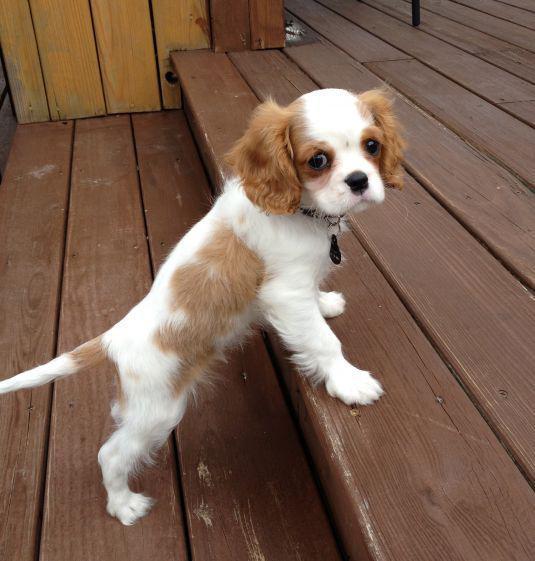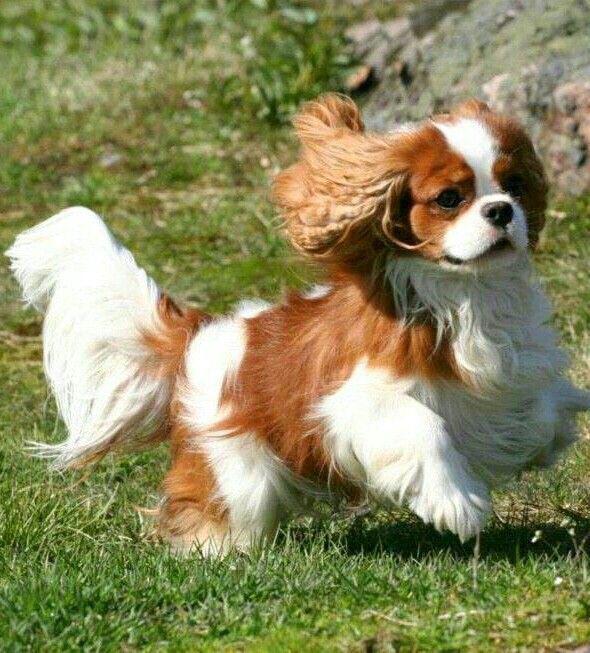The first image is the image on the left, the second image is the image on the right. Examine the images to the left and right. Is the description "There is at least one dog on top of grass." accurate? Answer yes or no. Yes. The first image is the image on the left, the second image is the image on the right. Given the left and right images, does the statement "At least 1 brown and white dog is in the grass." hold true? Answer yes or no. Yes. 